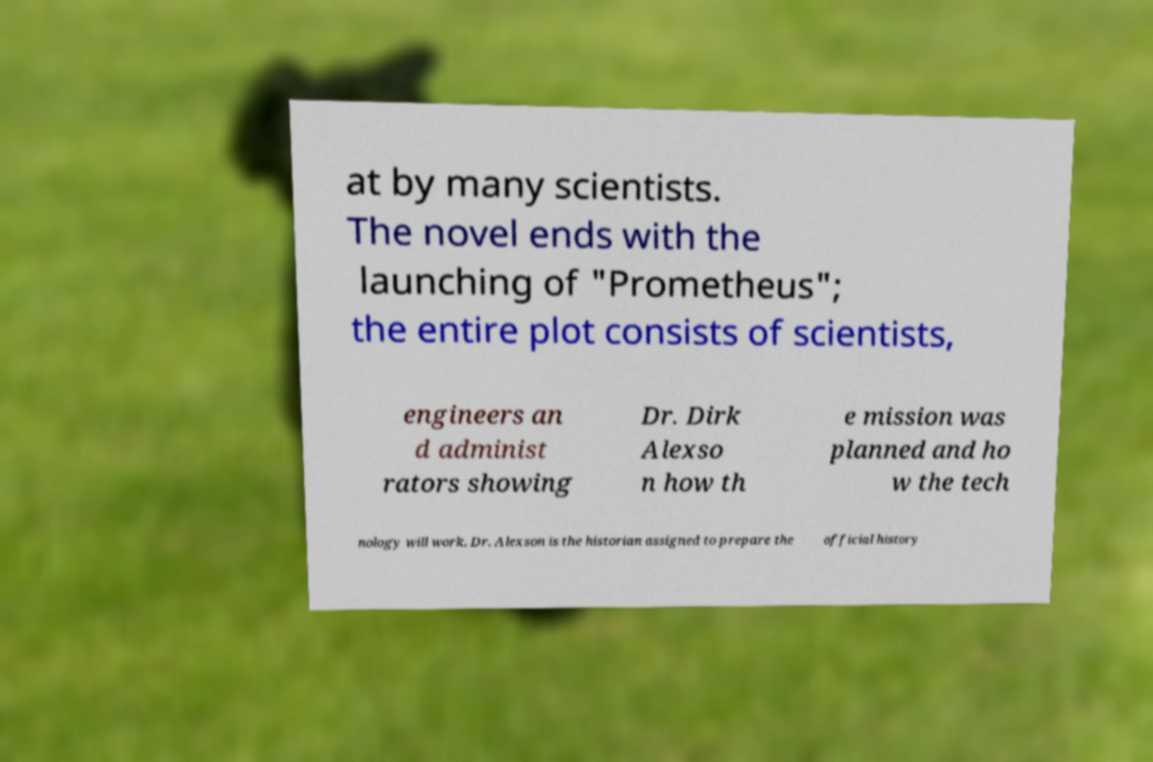I need the written content from this picture converted into text. Can you do that? at by many scientists. The novel ends with the launching of "Prometheus"; the entire plot consists of scientists, engineers an d administ rators showing Dr. Dirk Alexso n how th e mission was planned and ho w the tech nology will work. Dr. Alexson is the historian assigned to prepare the official history 